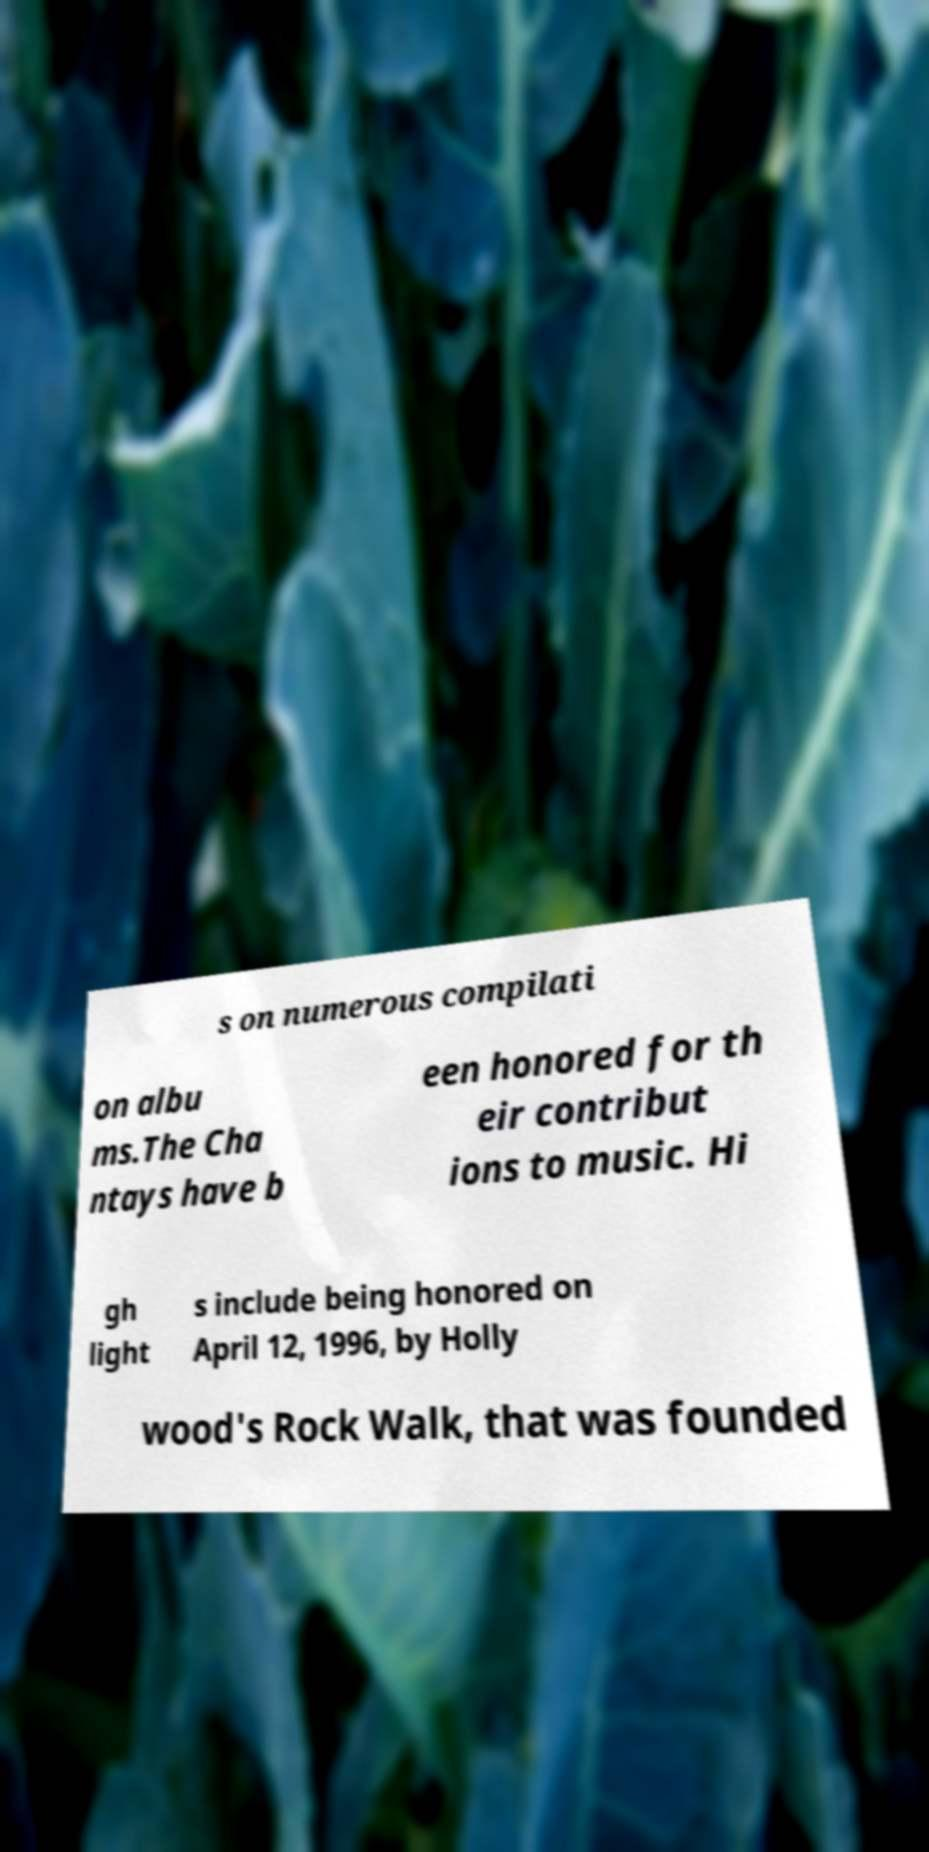Please identify and transcribe the text found in this image. s on numerous compilati on albu ms.The Cha ntays have b een honored for th eir contribut ions to music. Hi gh light s include being honored on April 12, 1996, by Holly wood's Rock Walk, that was founded 